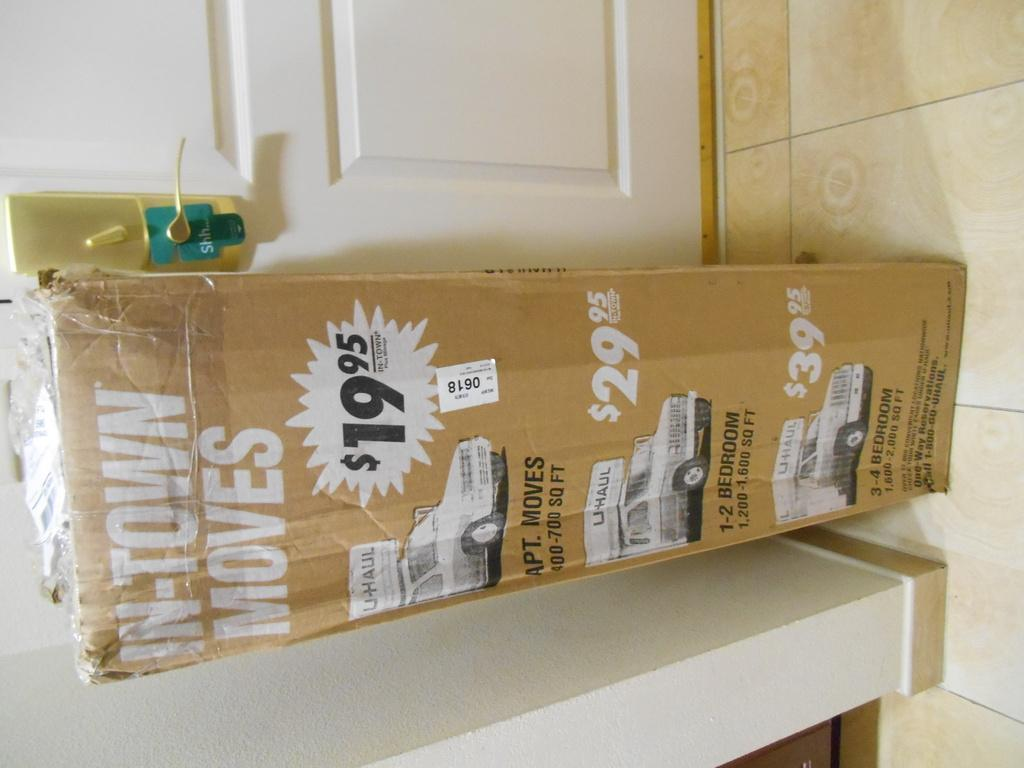<image>
Relay a brief, clear account of the picture shown. A long U haul box advertising $19.95 deals. 